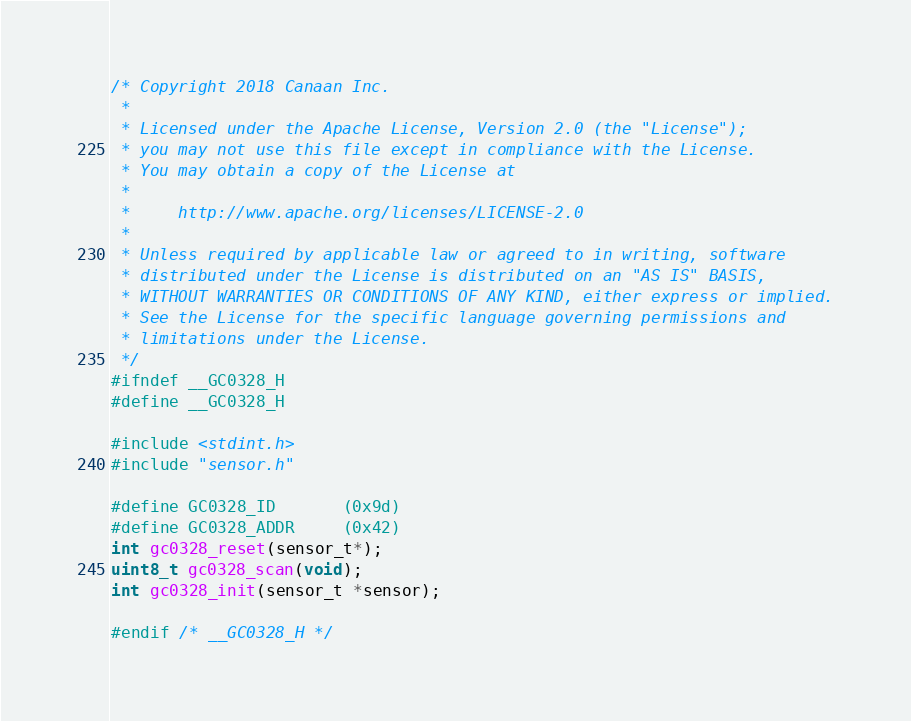<code> <loc_0><loc_0><loc_500><loc_500><_C_>/* Copyright 2018 Canaan Inc.
 *
 * Licensed under the Apache License, Version 2.0 (the "License");
 * you may not use this file except in compliance with the License.
 * You may obtain a copy of the License at
 *
 *     http://www.apache.org/licenses/LICENSE-2.0
 *
 * Unless required by applicable law or agreed to in writing, software
 * distributed under the License is distributed on an "AS IS" BASIS,
 * WITHOUT WARRANTIES OR CONDITIONS OF ANY KIND, either express or implied.
 * See the License for the specific language governing permissions and
 * limitations under the License.
 */
#ifndef __GC0328_H
#define __GC0328_H

#include <stdint.h>
#include "sensor.h"

#define GC0328_ID       (0x9d)
#define GC0328_ADDR     (0x42)
int gc0328_reset(sensor_t*);
uint8_t gc0328_scan(void);
int gc0328_init(sensor_t *sensor);

#endif /* __GC0328_H */
</code> 